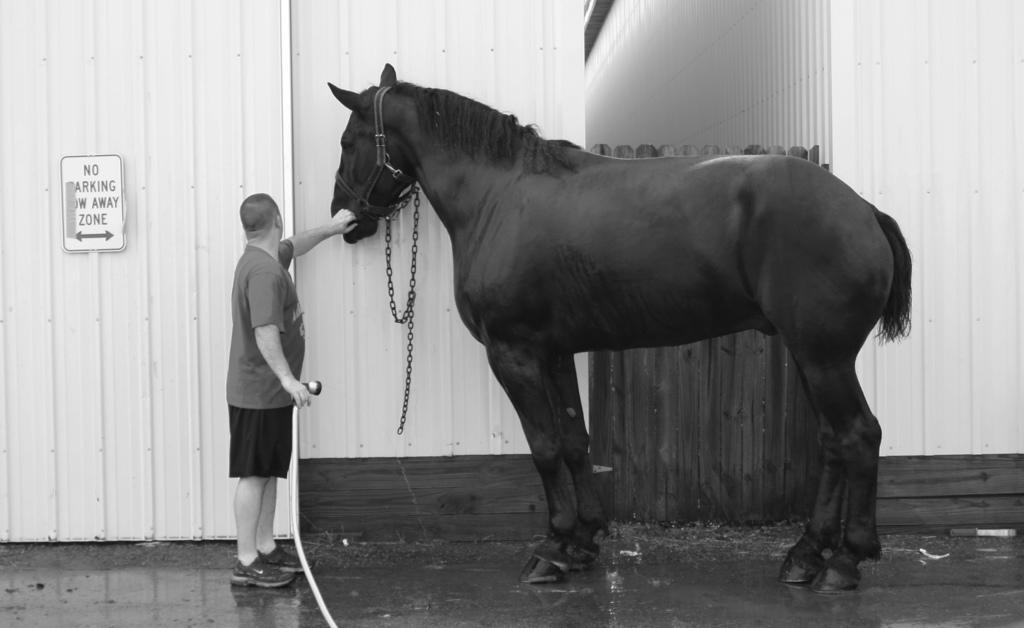Please provide a concise description of this image. here we can see that a person standing on the floor, and holding a horse with his hands, and here is the wall and board on it. 